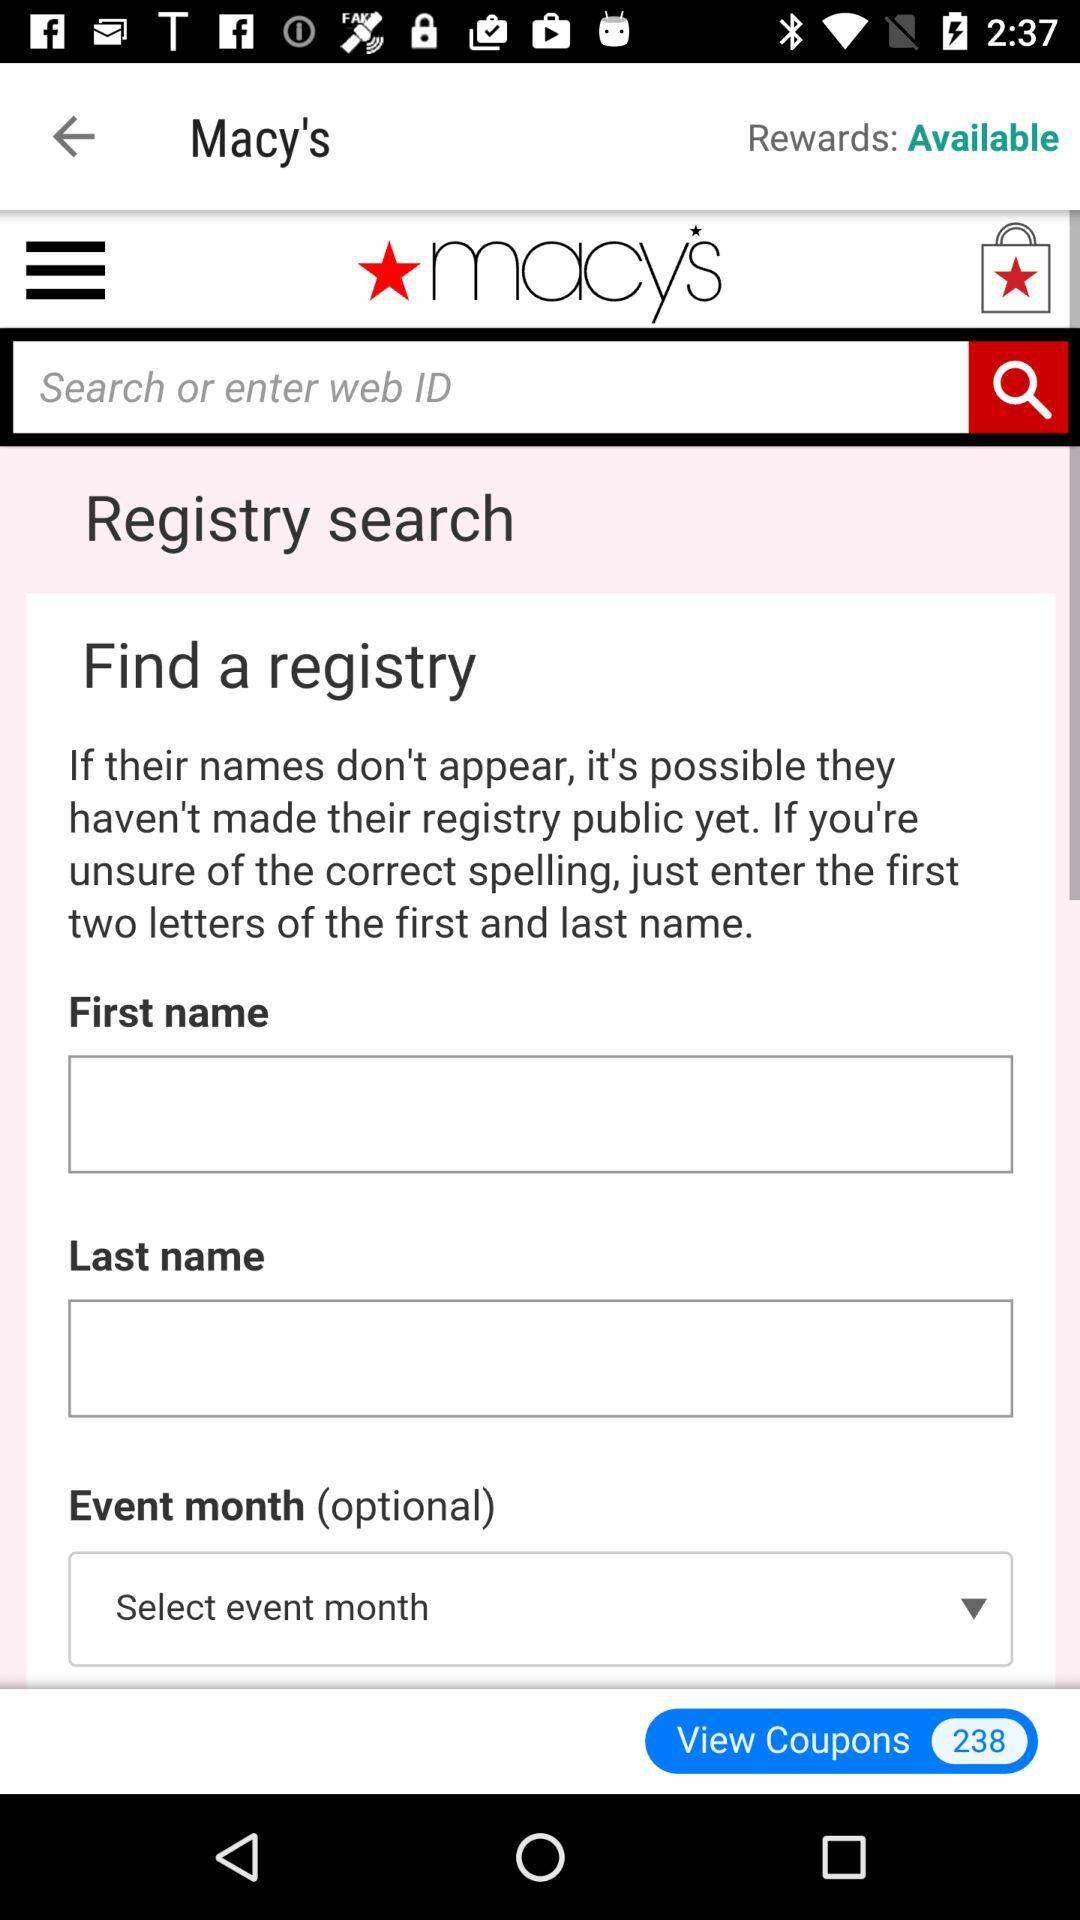How many coupons are there to view? There are 238 coupons to view. 